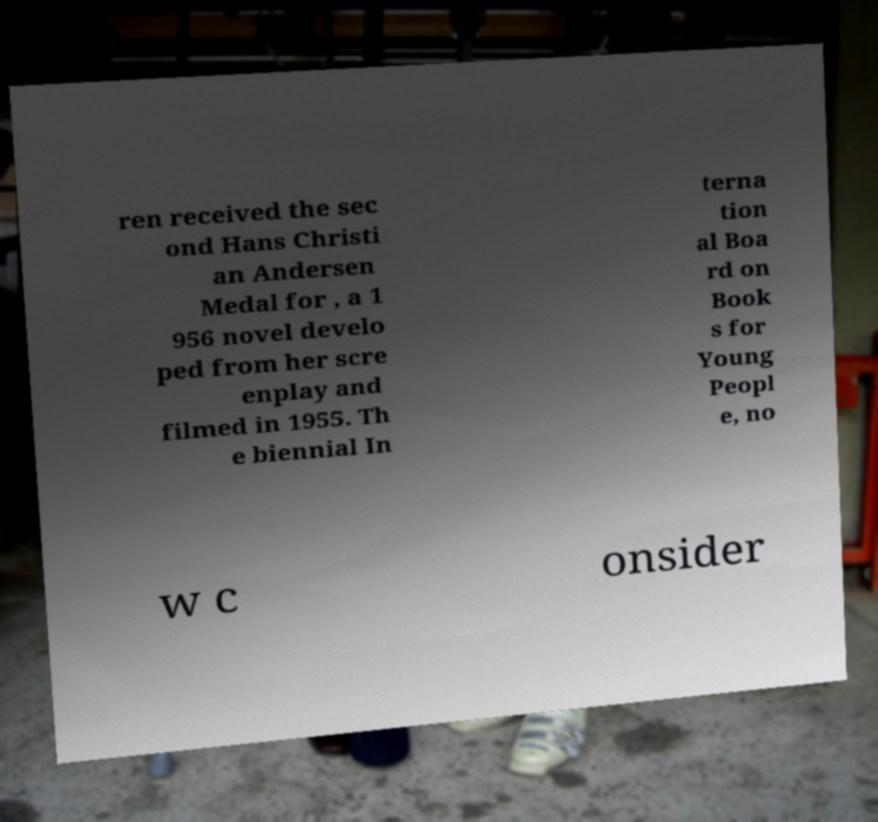Could you assist in decoding the text presented in this image and type it out clearly? ren received the sec ond Hans Christi an Andersen Medal for , a 1 956 novel develo ped from her scre enplay and filmed in 1955. Th e biennial In terna tion al Boa rd on Book s for Young Peopl e, no w c onsider 